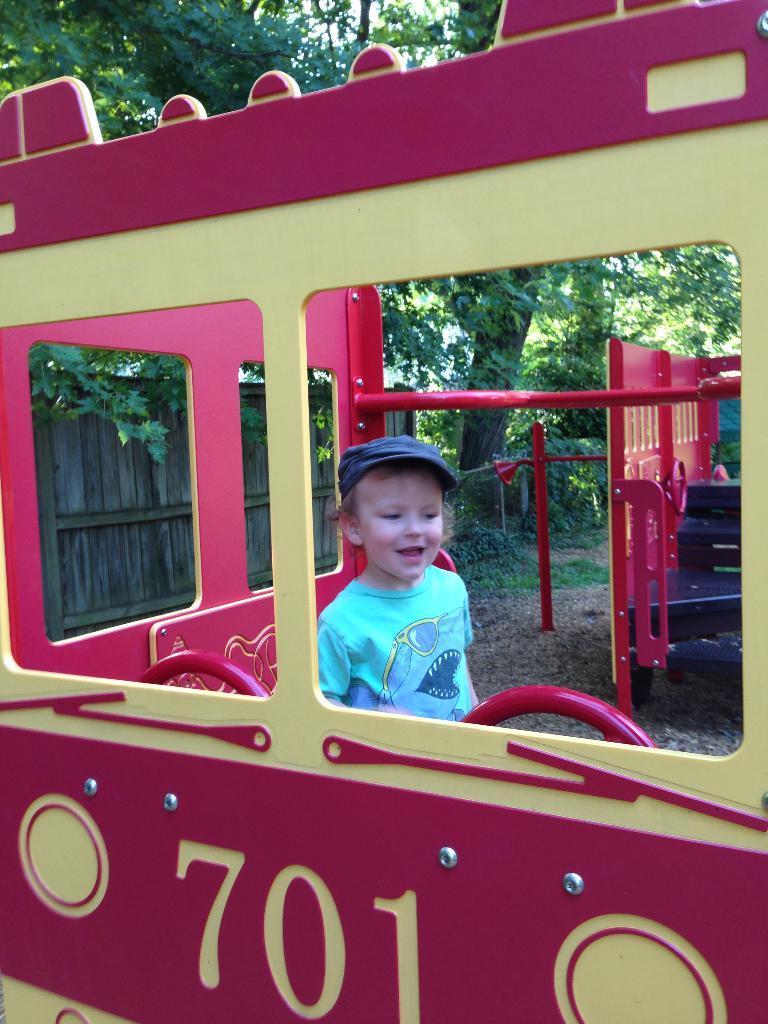Describe this image in one or two sentences. In this image I can see a vehicle, in the vehicle I can see a boy wearing a cap, inside the vehicle there is a wooden fence and some trees visible. 